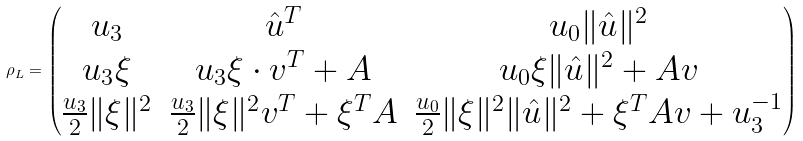Convert formula to latex. <formula><loc_0><loc_0><loc_500><loc_500>\rho _ { L } = \begin{pmatrix} u _ { 3 } & \hat { u } ^ { T } & u _ { 0 } \| \hat { u } \| ^ { 2 } \\ u _ { 3 } \xi & u _ { 3 } \xi \cdot v ^ { T } + A & u _ { 0 } \xi \| \hat { u } \| ^ { 2 } + A v \\ \frac { u _ { 3 } } { 2 } \| \xi \| ^ { 2 } & \frac { u _ { 3 } } { 2 } \| \xi \| ^ { 2 } v ^ { T } + \xi ^ { T } A & \frac { u _ { 0 } } { 2 } \| \xi \| ^ { 2 } \| \hat { u } \| ^ { 2 } + \xi ^ { T } A v + u _ { 3 } ^ { - 1 } \end{pmatrix}</formula> 